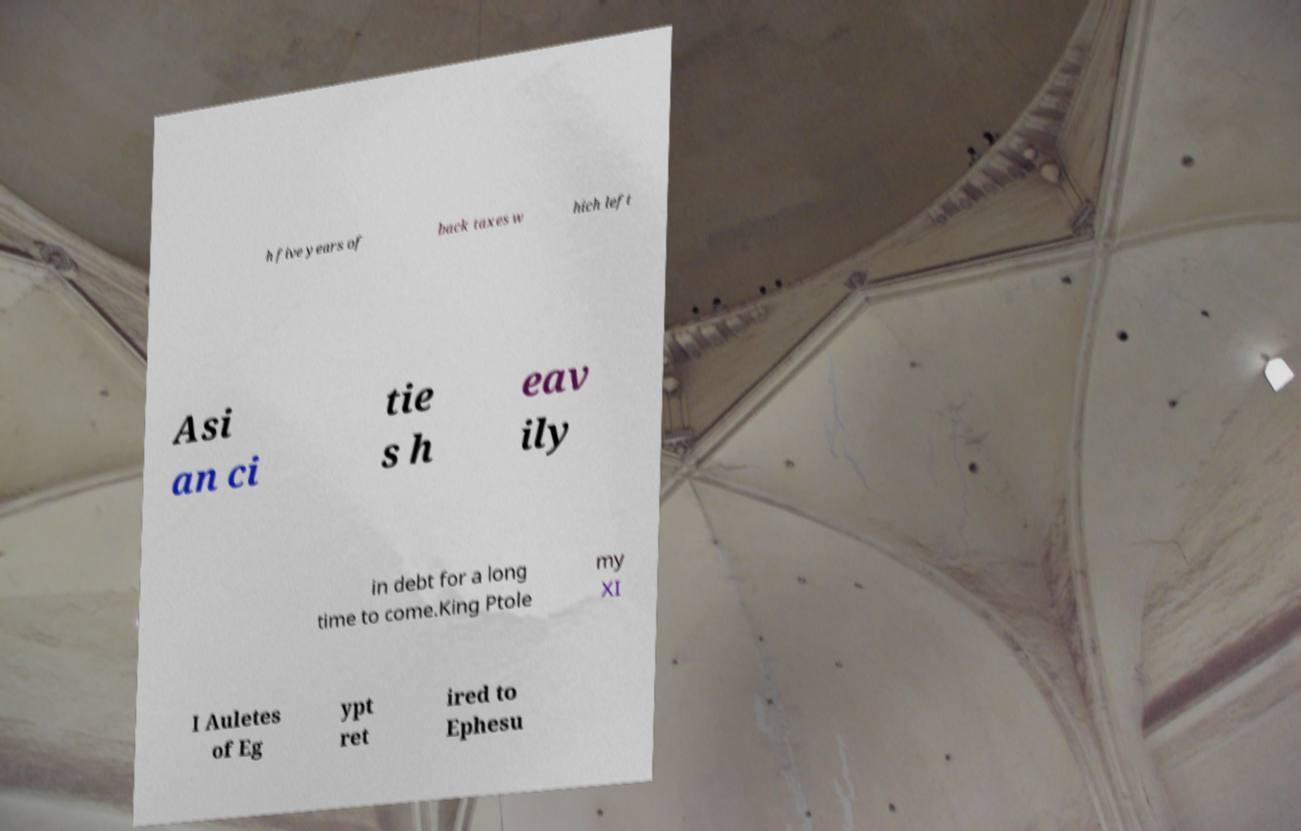Please read and relay the text visible in this image. What does it say? h five years of back taxes w hich left Asi an ci tie s h eav ily in debt for a long time to come.King Ptole my XI I Auletes of Eg ypt ret ired to Ephesu 